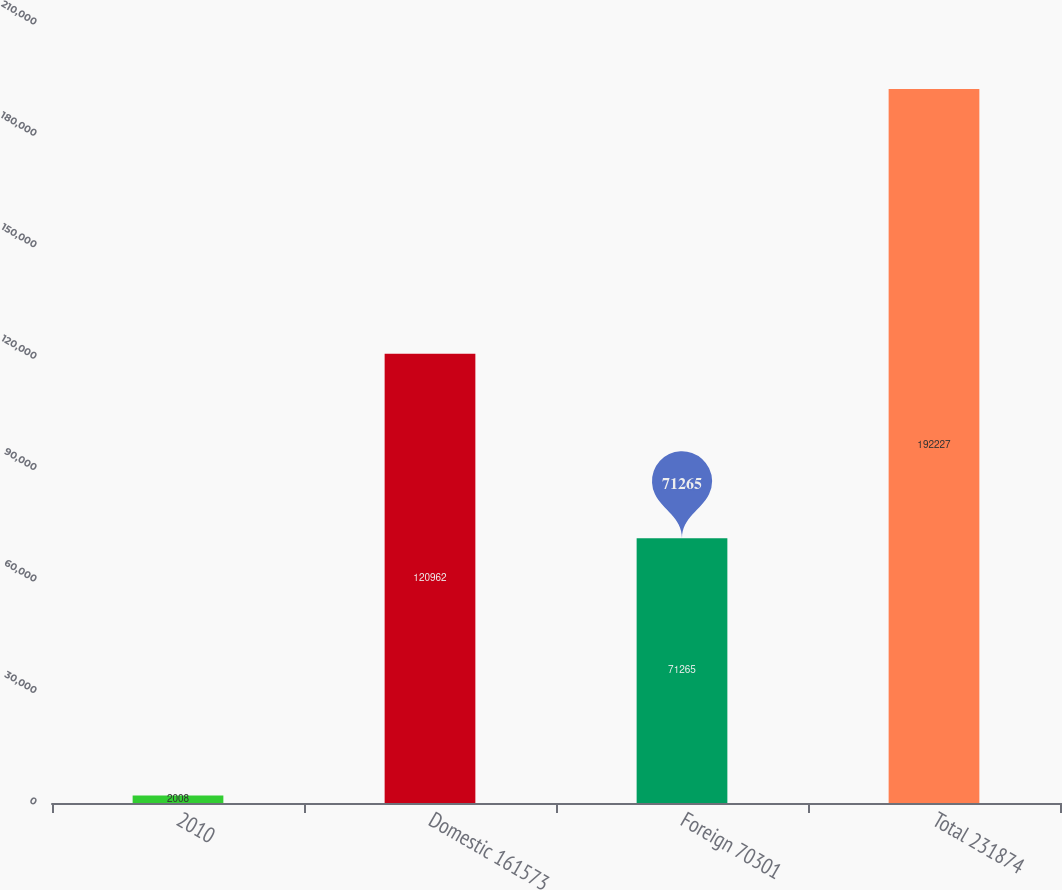Convert chart. <chart><loc_0><loc_0><loc_500><loc_500><bar_chart><fcel>2010<fcel>Domestic 161573<fcel>Foreign 70301<fcel>Total 231874<nl><fcel>2008<fcel>120962<fcel>71265<fcel>192227<nl></chart> 